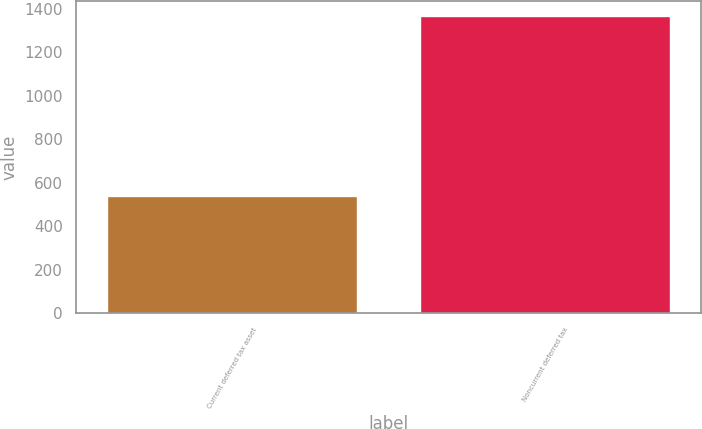<chart> <loc_0><loc_0><loc_500><loc_500><bar_chart><fcel>Current deferred tax asset<fcel>Noncurrent deferred tax<nl><fcel>539<fcel>1367<nl></chart> 